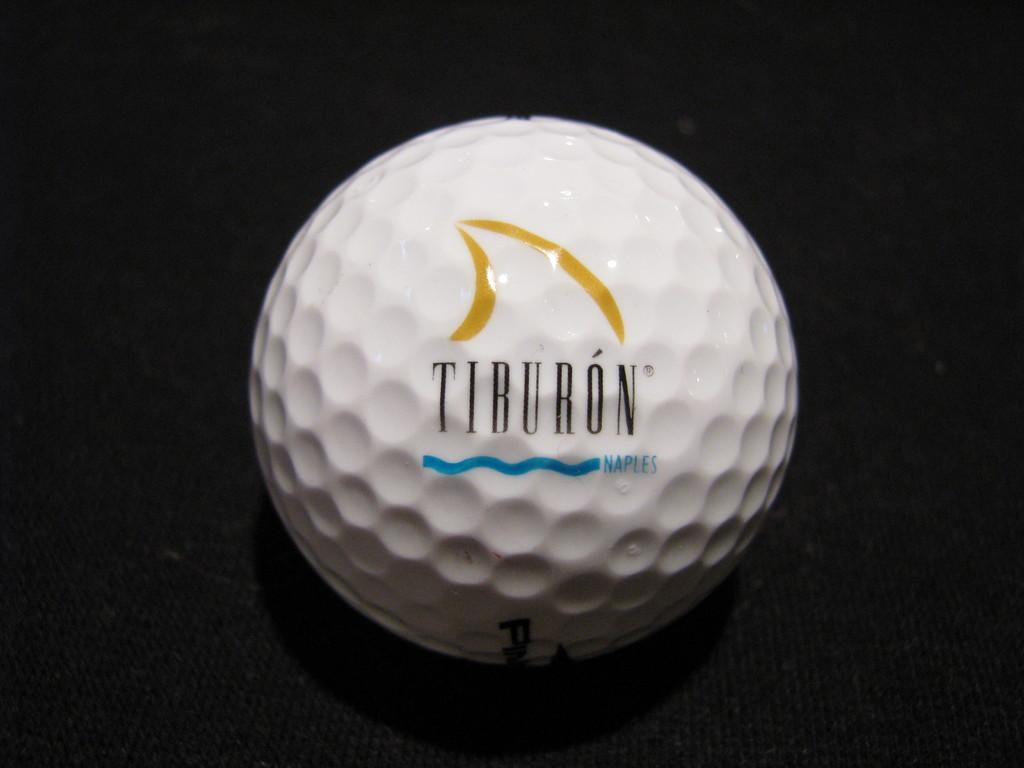Provide a one-sentence caption for the provided image. Black circle covering part of a Tiburon golfball. 